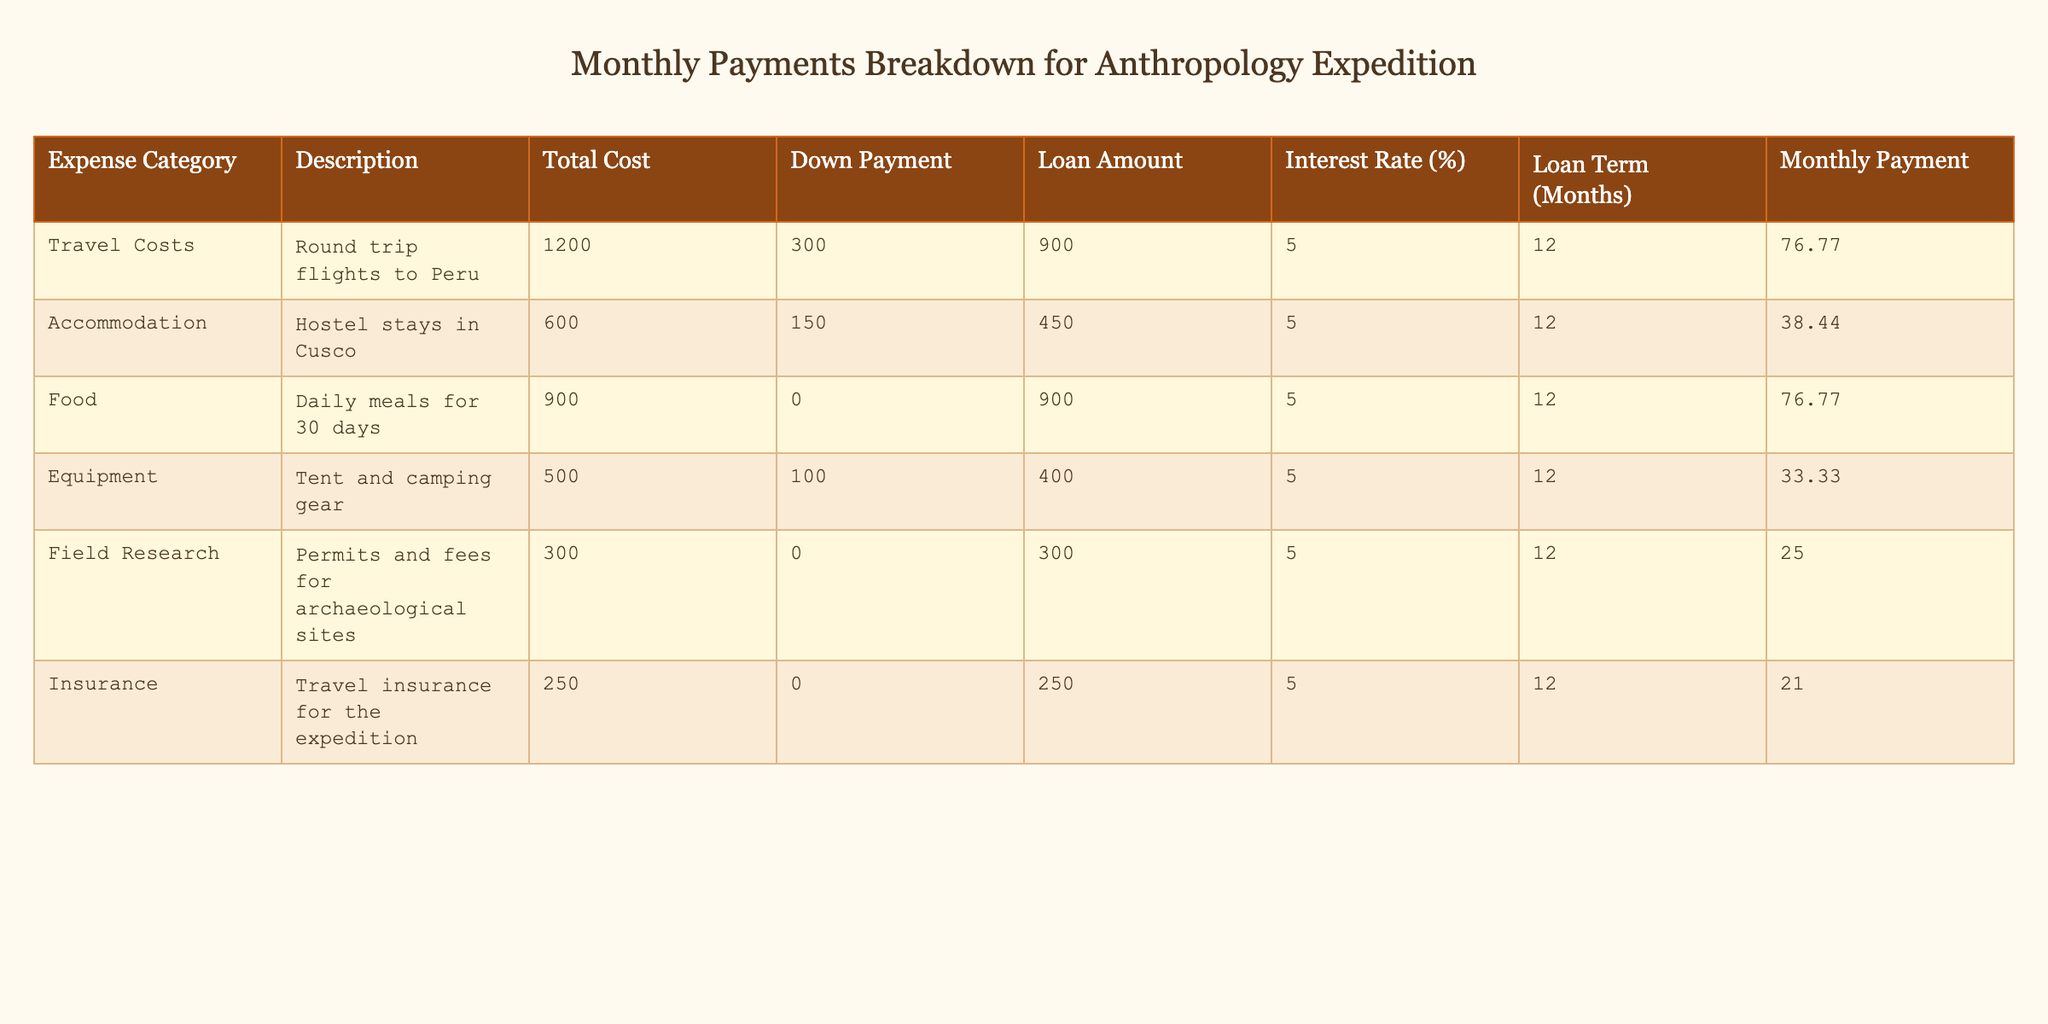What is the total cost of travel costs? The total cost of travel costs is directly presented in the table under the 'Total Cost' column for the 'Travel Costs' row, which shows 1200.
Answer: 1200 What is the monthly payment for accommodation? The monthly payment for accommodation is found in the 'Monthly Payment' column corresponding to the 'Accommodation' row, which lists the value as 38.44.
Answer: 38.44 What is the average monthly payment across all categories? To find the average, sum all monthly payments: 76.77 + 38.44 + 76.77 + 33.33 + 25 + 21 = 271.31. Then, divide by the total number of categories (6): 271.31 / 6 ≈ 45.22.
Answer: 45.22 Is the loan amount for food higher than that for equipment? The loan amount for food is 900 and for equipment is 400. Since 900 is greater than 400, the answer is yes.
Answer: Yes How much total monthly payment is allocated to travel and food combined? The monthly payment for travel is 76.77 and for food is also 76.77. Adding these gives 76.77 + 76.77 = 153.54.
Answer: 153.54 What is the total insurance cost compared to field research costs? The total insurance cost is 250 and the field research costs amount to 300. Since 250 is less than 300, the comparison shows that insurance cost is lower.
Answer: Lower What is the highest monthly payment among all categories? The monthly payments listed are 76.77 (travel), 38.44 (accommodation), 76.77 (food), 33.33 (equipment), 25 (field research), and 21 (insurance). The highest value observed is 76.77.
Answer: 76.77 How much lower is the loan amount for equipment compared to total costs for field research? The loan amount for equipment is 400, while total costs for field research are 300. The difference is 400 - 300 = 100, indicating the loan for equipment is higher, not lower.
Answer: Equipment is higher What percentage of the total costs does the 'Insurance' represent? The total cost of all categories is 1200 + 600 + 900 + 500 + 300 + 250 = 3750. The insurance cost is 250. To find the percentage, calculate (250 / 3750) * 100 = 6.67%.
Answer: 6.67% 